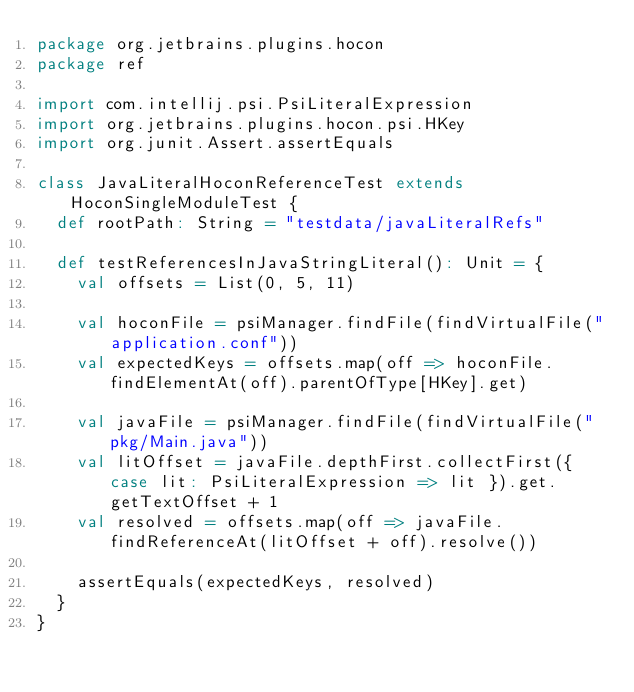<code> <loc_0><loc_0><loc_500><loc_500><_Scala_>package org.jetbrains.plugins.hocon
package ref

import com.intellij.psi.PsiLiteralExpression
import org.jetbrains.plugins.hocon.psi.HKey
import org.junit.Assert.assertEquals

class JavaLiteralHoconReferenceTest extends HoconSingleModuleTest {
  def rootPath: String = "testdata/javaLiteralRefs"

  def testReferencesInJavaStringLiteral(): Unit = {
    val offsets = List(0, 5, 11)

    val hoconFile = psiManager.findFile(findVirtualFile("application.conf"))
    val expectedKeys = offsets.map(off => hoconFile.findElementAt(off).parentOfType[HKey].get)

    val javaFile = psiManager.findFile(findVirtualFile("pkg/Main.java"))
    val litOffset = javaFile.depthFirst.collectFirst({ case lit: PsiLiteralExpression => lit }).get.getTextOffset + 1
    val resolved = offsets.map(off => javaFile.findReferenceAt(litOffset + off).resolve())

    assertEquals(expectedKeys, resolved)
  }
}
</code> 